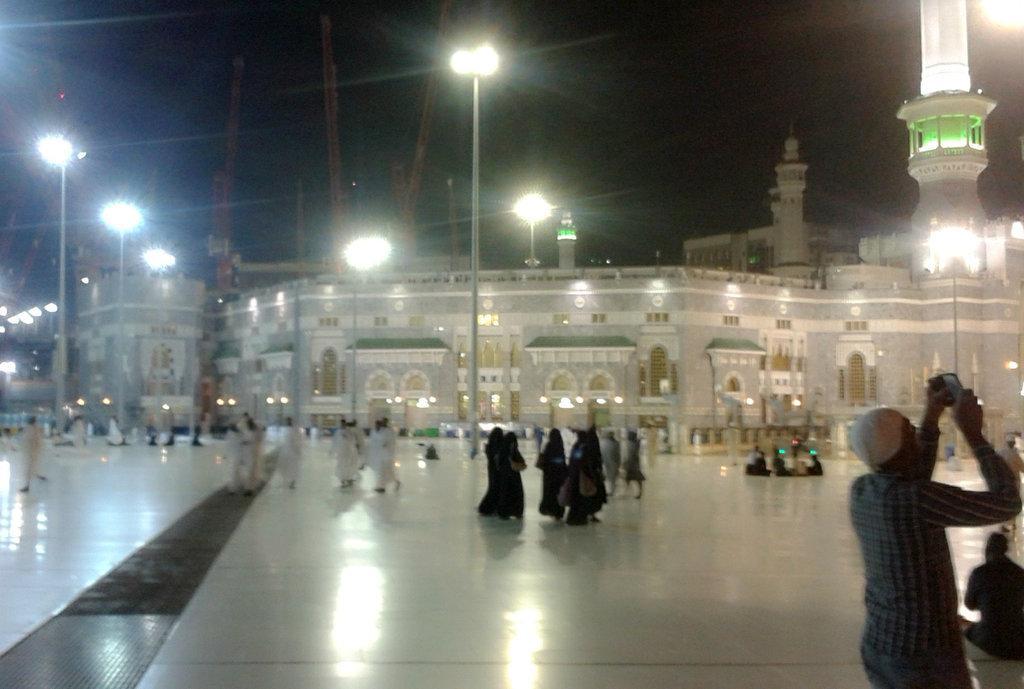Can you describe this image briefly? In this image I can see the group of people with white and black color dresses. In the back I can see the building with lights and also there are light poles. And there is a black background. 